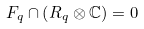<formula> <loc_0><loc_0><loc_500><loc_500>F _ { q } \cap \left ( R _ { q } \otimes \mathbb { C } \right ) = 0</formula> 